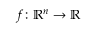Convert formula to latex. <formula><loc_0><loc_0><loc_500><loc_500>f \colon \mathbb { R } ^ { n } \to \mathbb { R }</formula> 